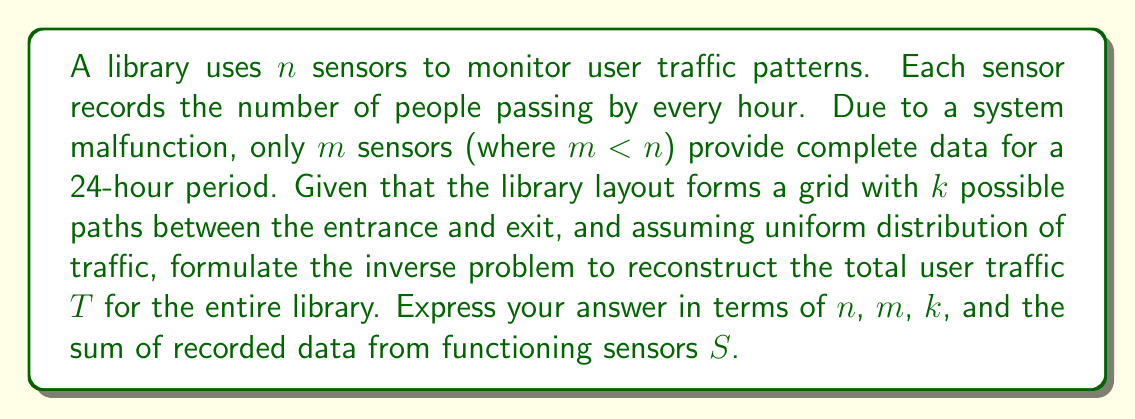Solve this math problem. To reconstruct the total user traffic pattern from partial sensor data, we need to follow these steps:

1) First, we need to understand what data we have:
   - Total number of sensors: $n$
   - Number of functioning sensors: $m$
   - Sum of data from functioning sensors: $S$
   - Number of possible paths: $k$

2) Assuming uniform distribution of traffic, each sensor should, on average, record the same amount of traffic. Let's call the average traffic per sensor $x$.

3) For the $m$ functioning sensors, we know:
   $$ mx = S $$

4) Therefore, the average traffic per sensor is:
   $$ x = \frac{S}{m} $$

5) If all $n$ sensors were functioning, the total recorded traffic would be:
   $$ nx = n\frac{S}{m} $$

6) However, this is not the total library traffic, as each user may be counted by multiple sensors depending on their path.

7) Given $k$ possible paths, and assuming uniform distribution, each user is counted on average $\frac{n}{k}$ times.

8) Therefore, to get the total user traffic $T$, we need to divide the total recorded traffic by the average number of times each user is counted:

   $$ T = \frac{nx}{\frac{n}{k}} = \frac{n\frac{S}{m}}{\frac{n}{k}} = k\frac{S}{m} $$

This formula represents the inverse problem of reconstructing the total user traffic from partial sensor data.
Answer: $T = k\frac{S}{m}$ 